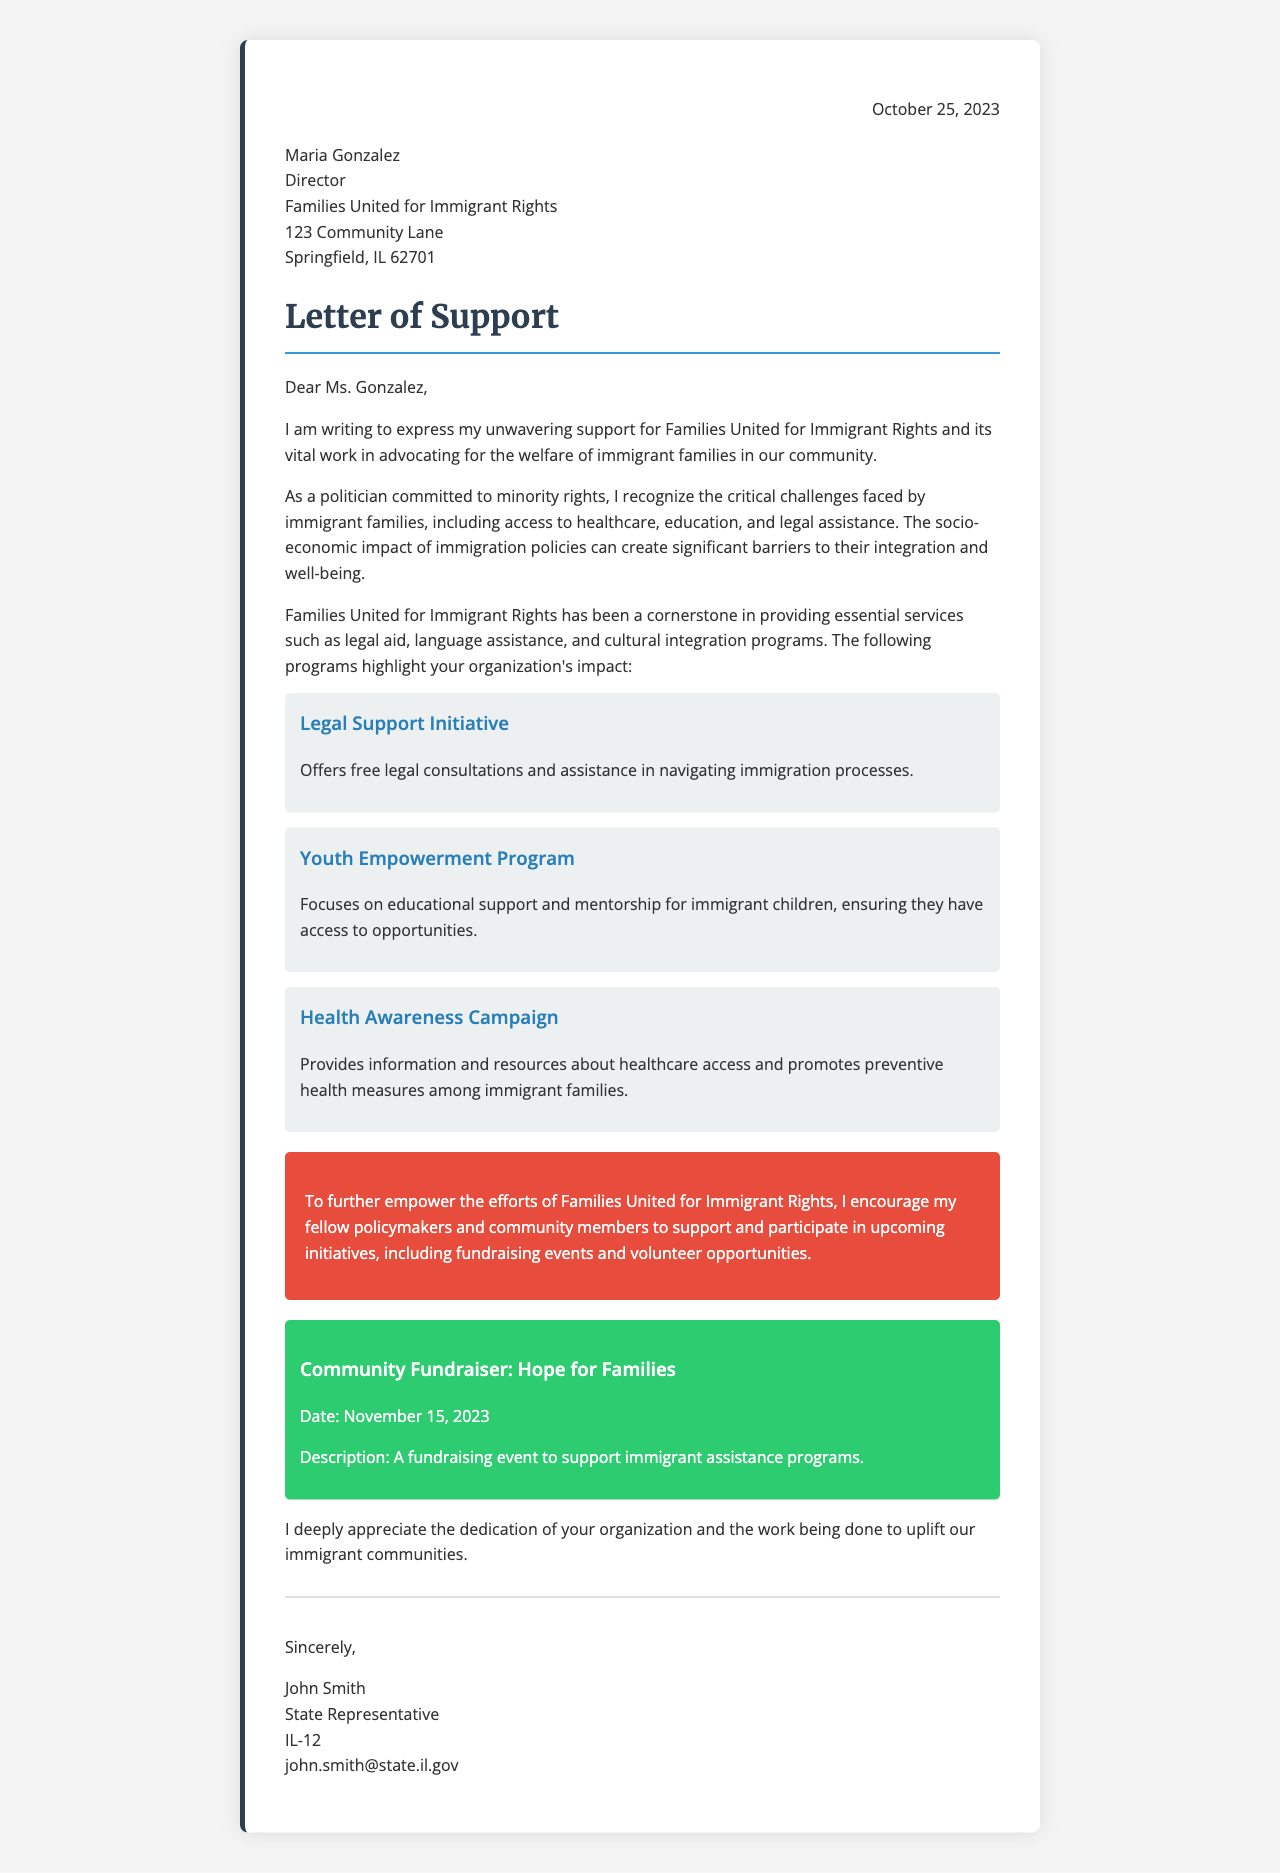What is the date of the letter? The date of the letter is mentioned at the top of the document.
Answer: October 25, 2023 Who is the director of Families United for Immigrant Rights? The director's name is provided in the recipient section of the letter.
Answer: Maria Gonzalez What is the title of the first program mentioned? The title of the program is explicitly stated in a separate section of the letter.
Answer: Legal Support Initiative When is the community fundraiser scheduled? The date of the community fundraiser is stated in the event section of the letter.
Answer: November 15, 2023 What type of campaign does the Health Awareness Campaign focus on? The focus of the campaign is mentioned in its description within the document.
Answer: Healthcare access Why is Families United for Immigrant Rights significant according to the letter? The letter discusses the importance of the organization in advocating for immigrant families.
Answer: Essential services What is the main call to action presented in the letter? The main call to action is highlighted in a specific section of the letter.
Answer: Support and participate in upcoming initiatives Who is the author of the letter? The author's name is mentioned at the end of the letter in the signature section.
Answer: John Smith 